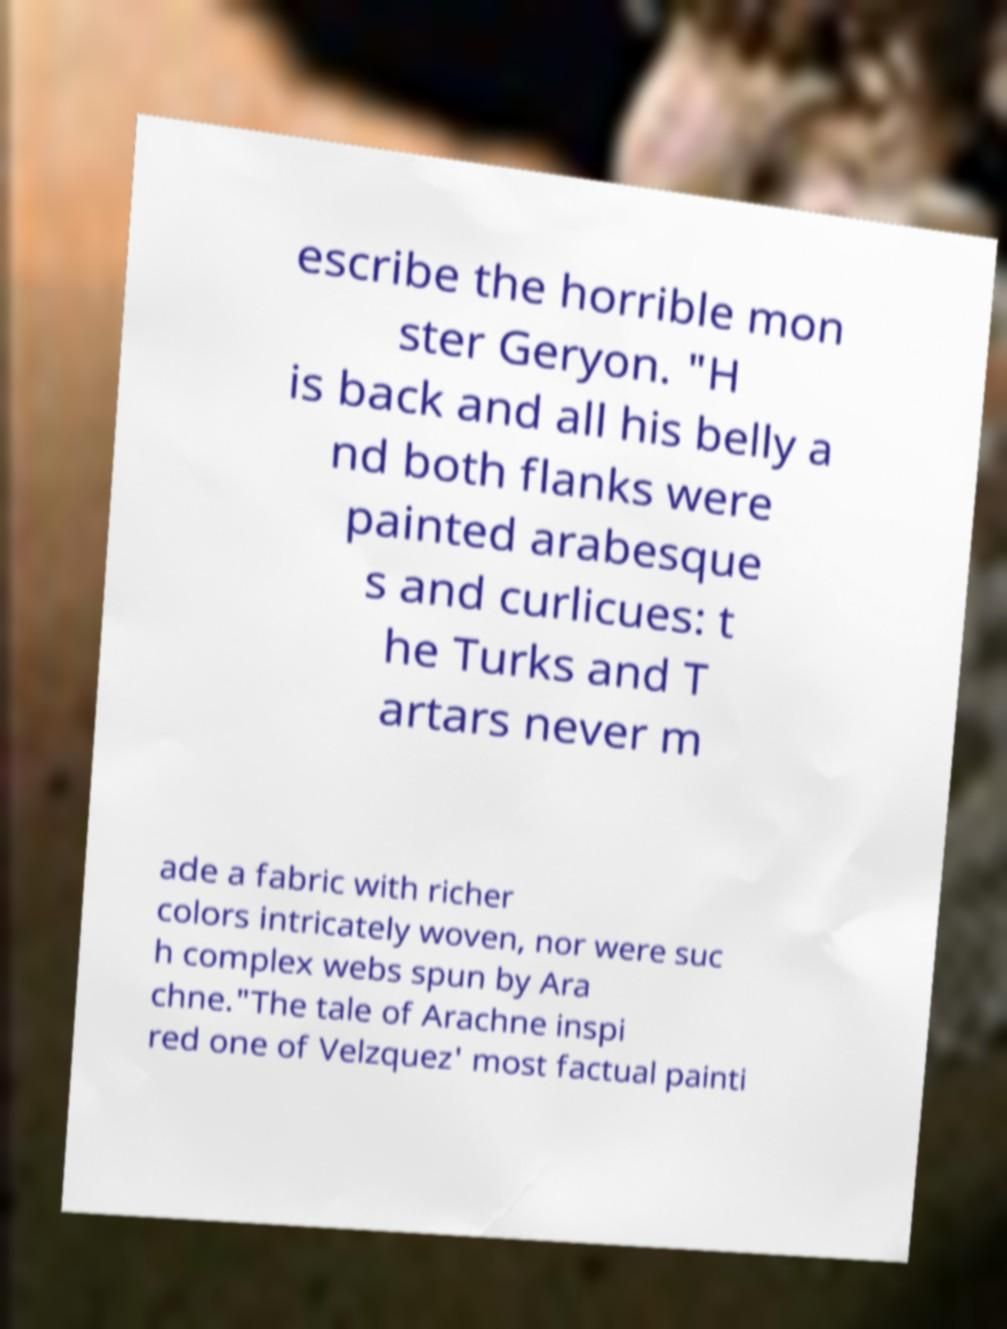Could you extract and type out the text from this image? escribe the horrible mon ster Geryon. "H is back and all his belly a nd both flanks were painted arabesque s and curlicues: t he Turks and T artars never m ade a fabric with richer colors intricately woven, nor were suc h complex webs spun by Ara chne."The tale of Arachne inspi red one of Velzquez' most factual painti 